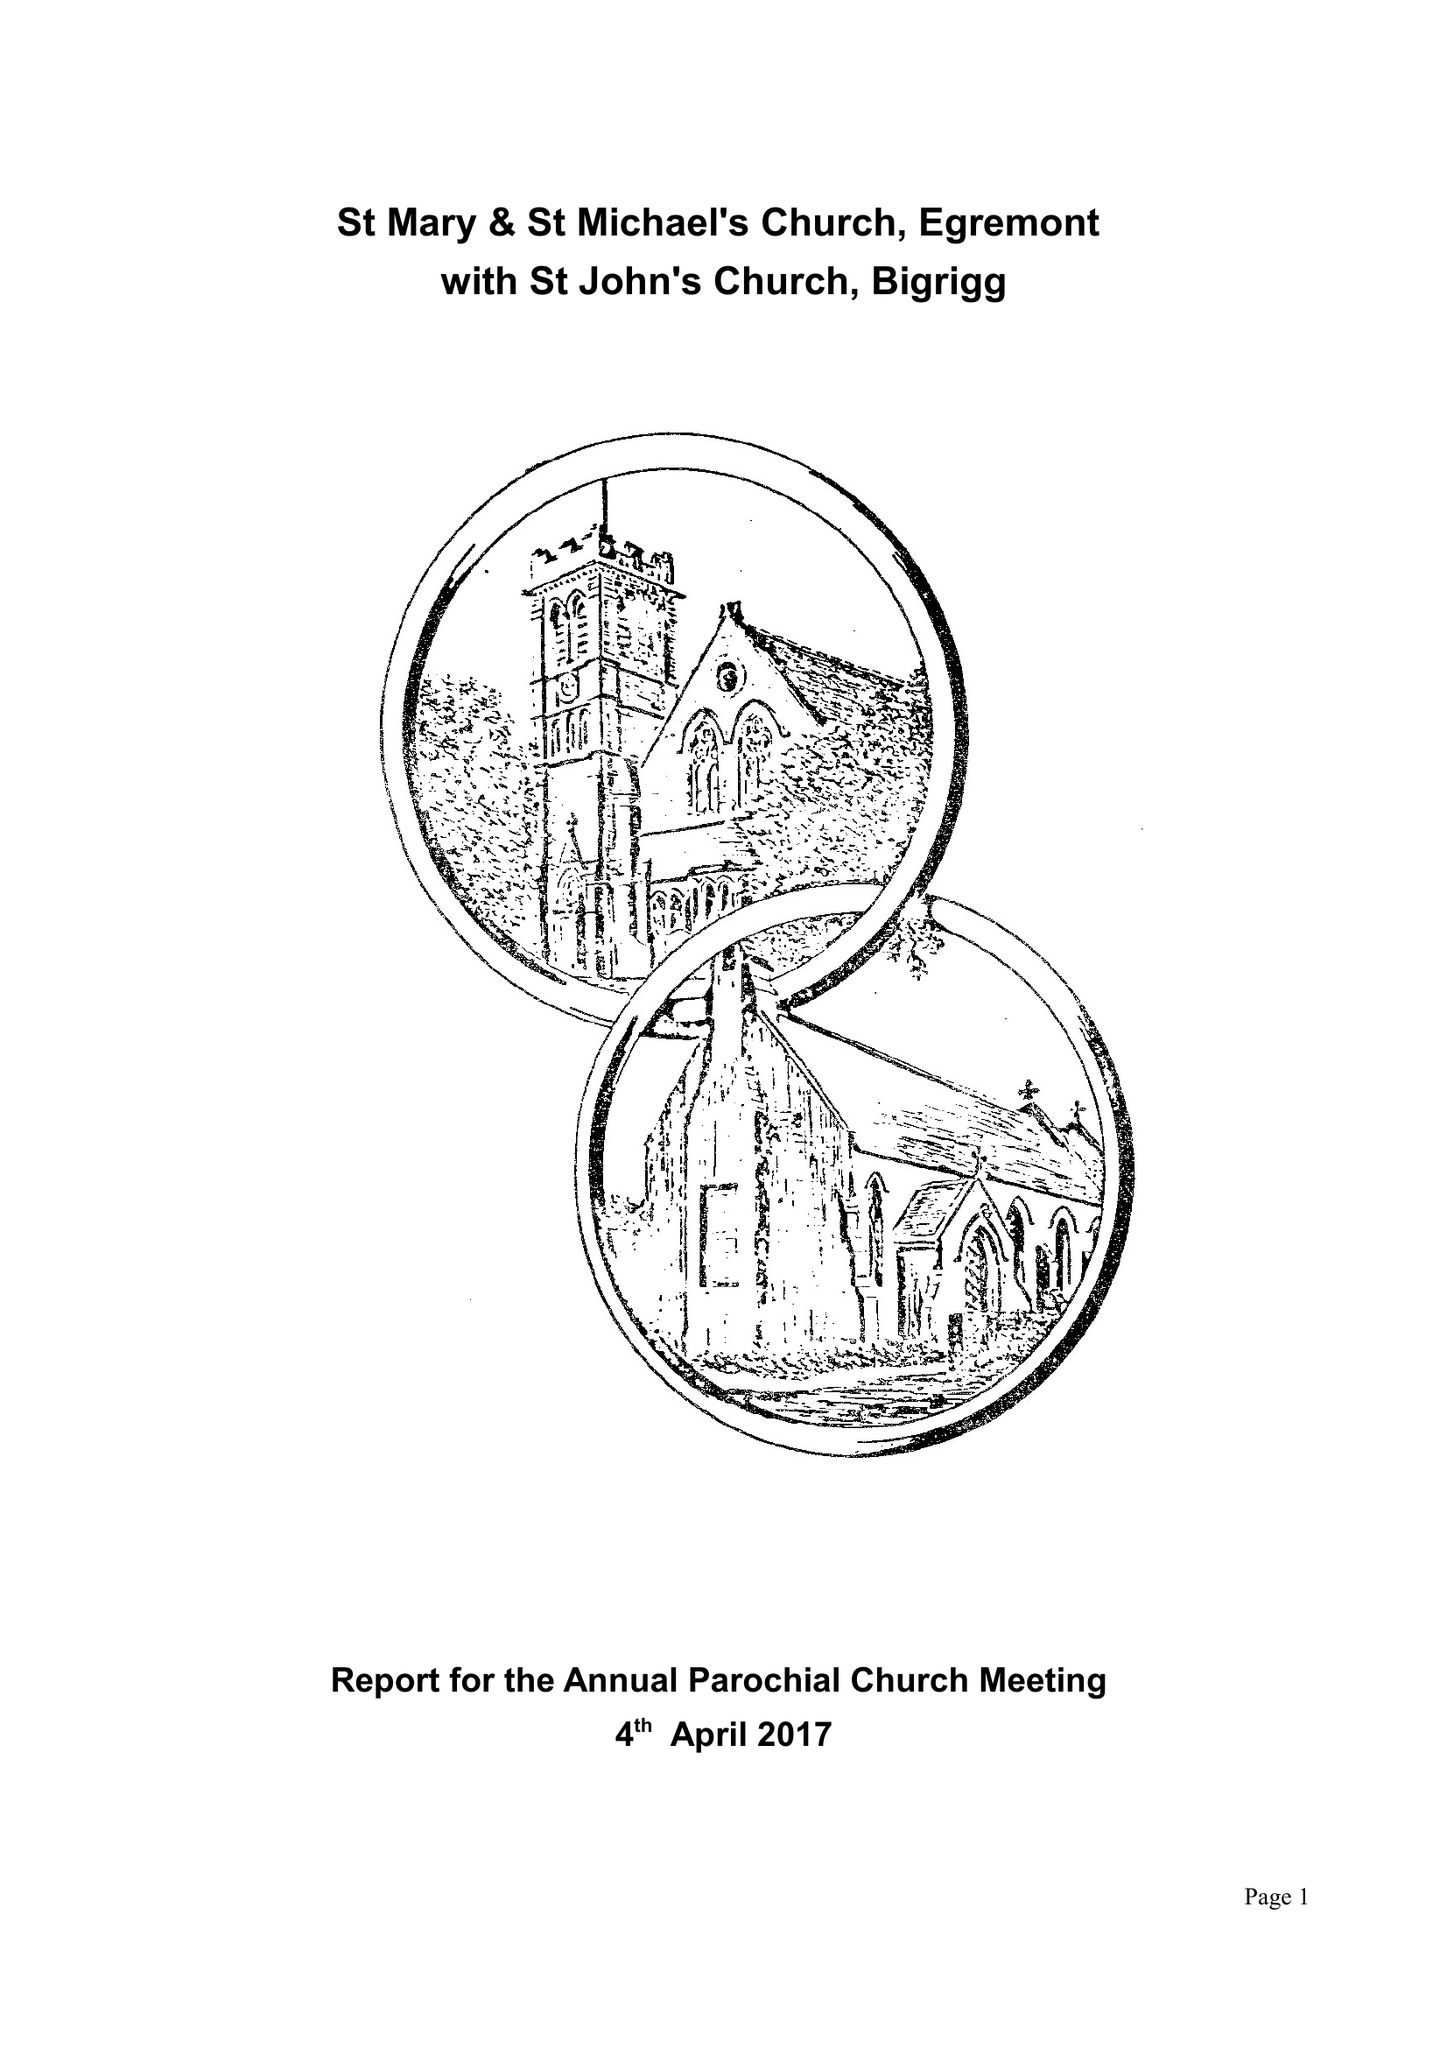What is the value for the charity_number?
Answer the question using a single word or phrase. 1136966 